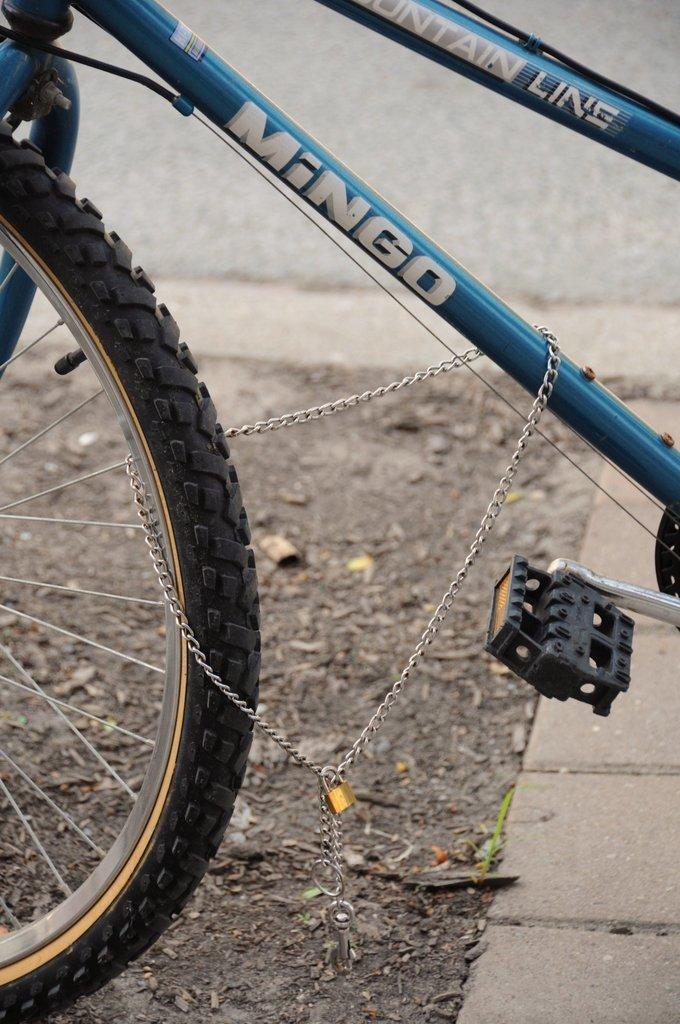Could you give a brief overview of what you see in this image? In this image in front there is a cycle on the road. 